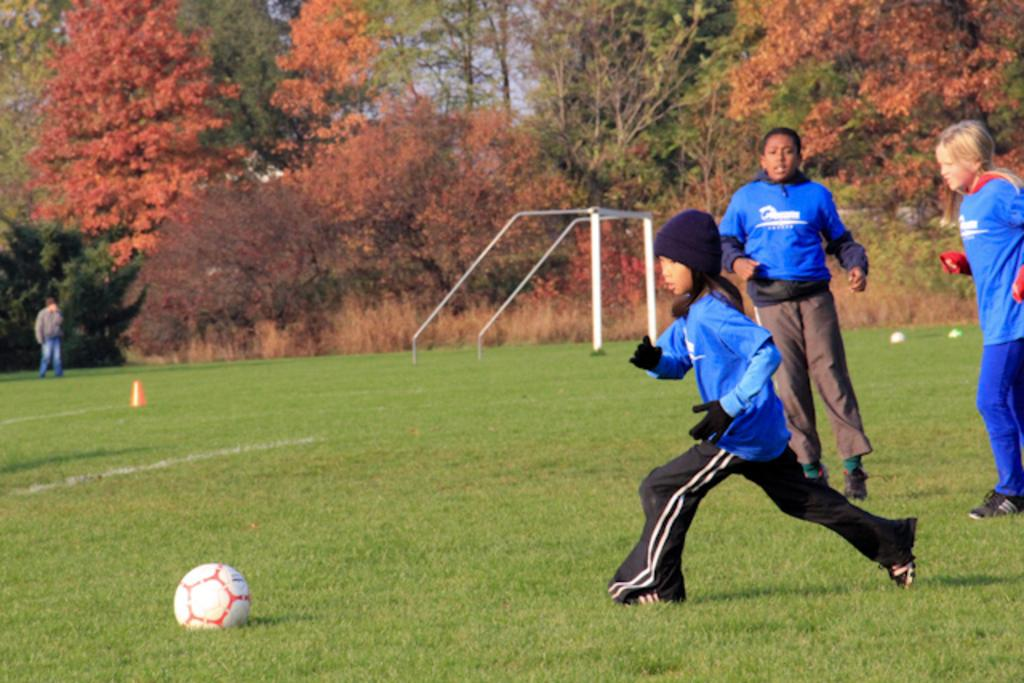Who is present in the image? There are children in the image. Where are the children located? The children are standing in a sports ground. What object can be seen in the image? There is a ball in the image. What type of natural elements are visible in the image? There are trees in the image. What is visible in the background of the image? The sky is visible in the image. What type of heart can be seen beating in the image? There is no heart visible in the image; it features children in a sports ground with a ball and trees. Does the existence of the children in the image prove the existence of life on other planets? The presence of children in the image does not provide any information about the existence of life on other planets. 